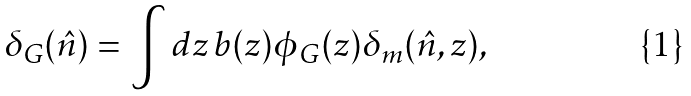Convert formula to latex. <formula><loc_0><loc_0><loc_500><loc_500>\delta _ { G } ( \hat { n } ) = \int d z \, b ( z ) \phi _ { G } ( z ) \delta _ { m } ( \hat { n } , z ) ,</formula> 